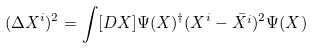<formula> <loc_0><loc_0><loc_500><loc_500>( \Delta X ^ { i } ) ^ { 2 } = \int [ D X ] \Psi ( X ) ^ { \dagger } ( X ^ { i } - \bar { X ^ { i } } ) ^ { 2 } \Psi ( X )</formula> 